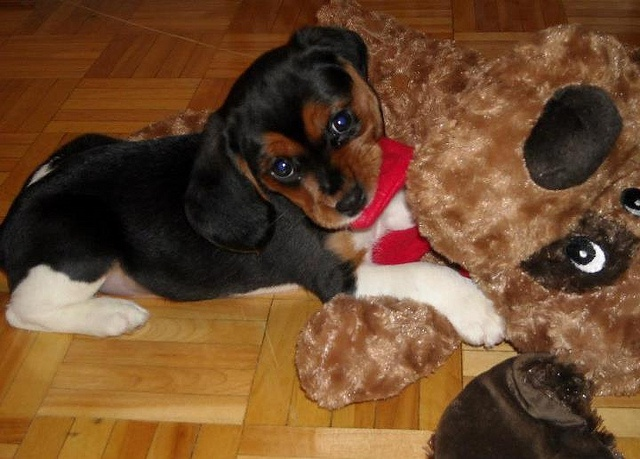Describe the objects in this image and their specific colors. I can see dog in maroon, black, lightgray, and tan tones and teddy bear in maroon, gray, and brown tones in this image. 